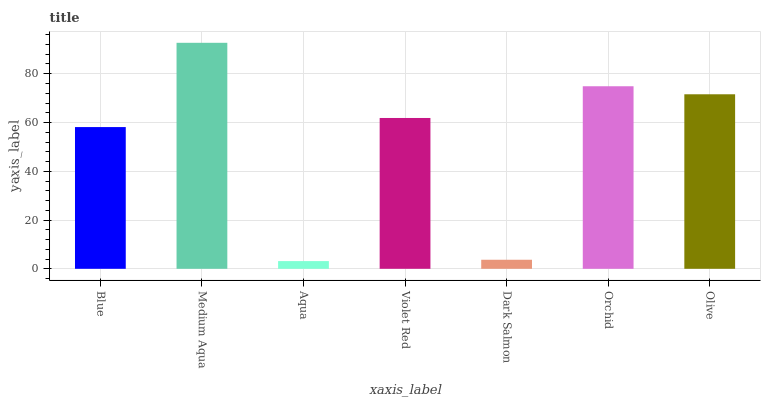Is Medium Aqua the maximum?
Answer yes or no. Yes. Is Medium Aqua the minimum?
Answer yes or no. No. Is Aqua the maximum?
Answer yes or no. No. Is Medium Aqua greater than Aqua?
Answer yes or no. Yes. Is Aqua less than Medium Aqua?
Answer yes or no. Yes. Is Aqua greater than Medium Aqua?
Answer yes or no. No. Is Medium Aqua less than Aqua?
Answer yes or no. No. Is Violet Red the high median?
Answer yes or no. Yes. Is Violet Red the low median?
Answer yes or no. Yes. Is Aqua the high median?
Answer yes or no. No. Is Olive the low median?
Answer yes or no. No. 